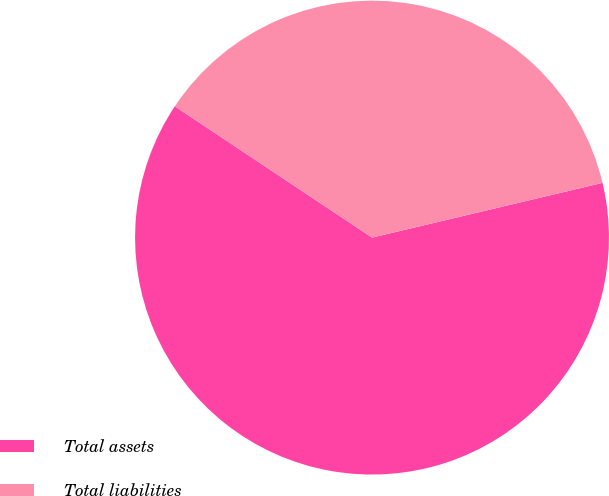Convert chart to OTSL. <chart><loc_0><loc_0><loc_500><loc_500><pie_chart><fcel>Total assets<fcel>Total liabilities<nl><fcel>63.06%<fcel>36.94%<nl></chart> 